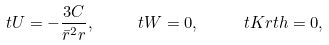<formula> <loc_0><loc_0><loc_500><loc_500>\ t U = - \frac { 3 C } { { \bar { r } } ^ { 2 } r } , \quad \ t W = 0 , \quad \ t K r t h = 0 ,</formula> 